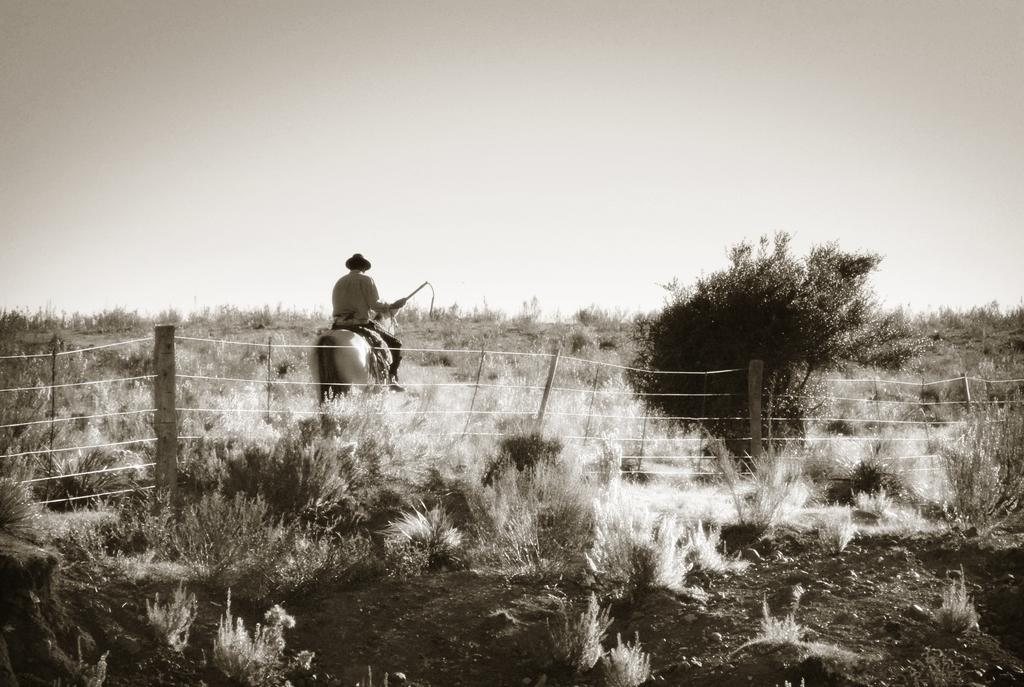What is the main subject of the image? There is a person in the image. What is the person doing in the image? The person is sitting on a horse. What type of vegetation can be seen in the image? There are plants and grass in the image. What type of button is the person wearing on their shirt in the image? There is no button visible on the person's shirt in the image. Can you tell me what the person's uncle is doing in the image? There is no uncle present in the image, only the person sitting on a horse. 